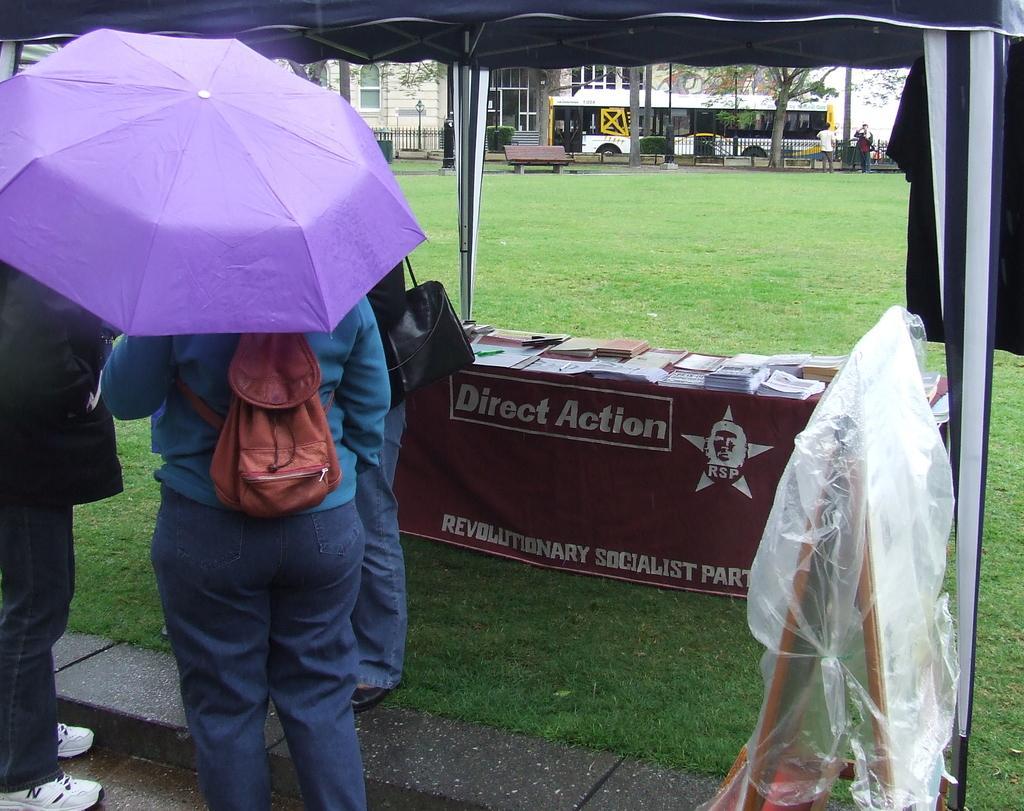How would you summarize this image in a sentence or two? In this image, we can see people standing and wearing bags and one of them is holding and umbrella. In the background, there is a stand covered with a cover and we can see a tent and there are books and papers on the table and we can see a cloth and rods and there are vehicles, buildings and some people and a bench, fence and trees. At the bottom, there is ground. 